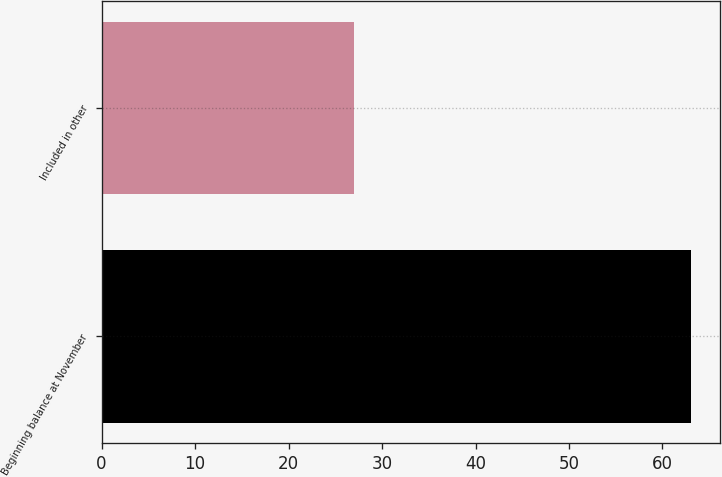Convert chart. <chart><loc_0><loc_0><loc_500><loc_500><bar_chart><fcel>Beginning balance at November<fcel>Included in other<nl><fcel>63<fcel>27<nl></chart> 